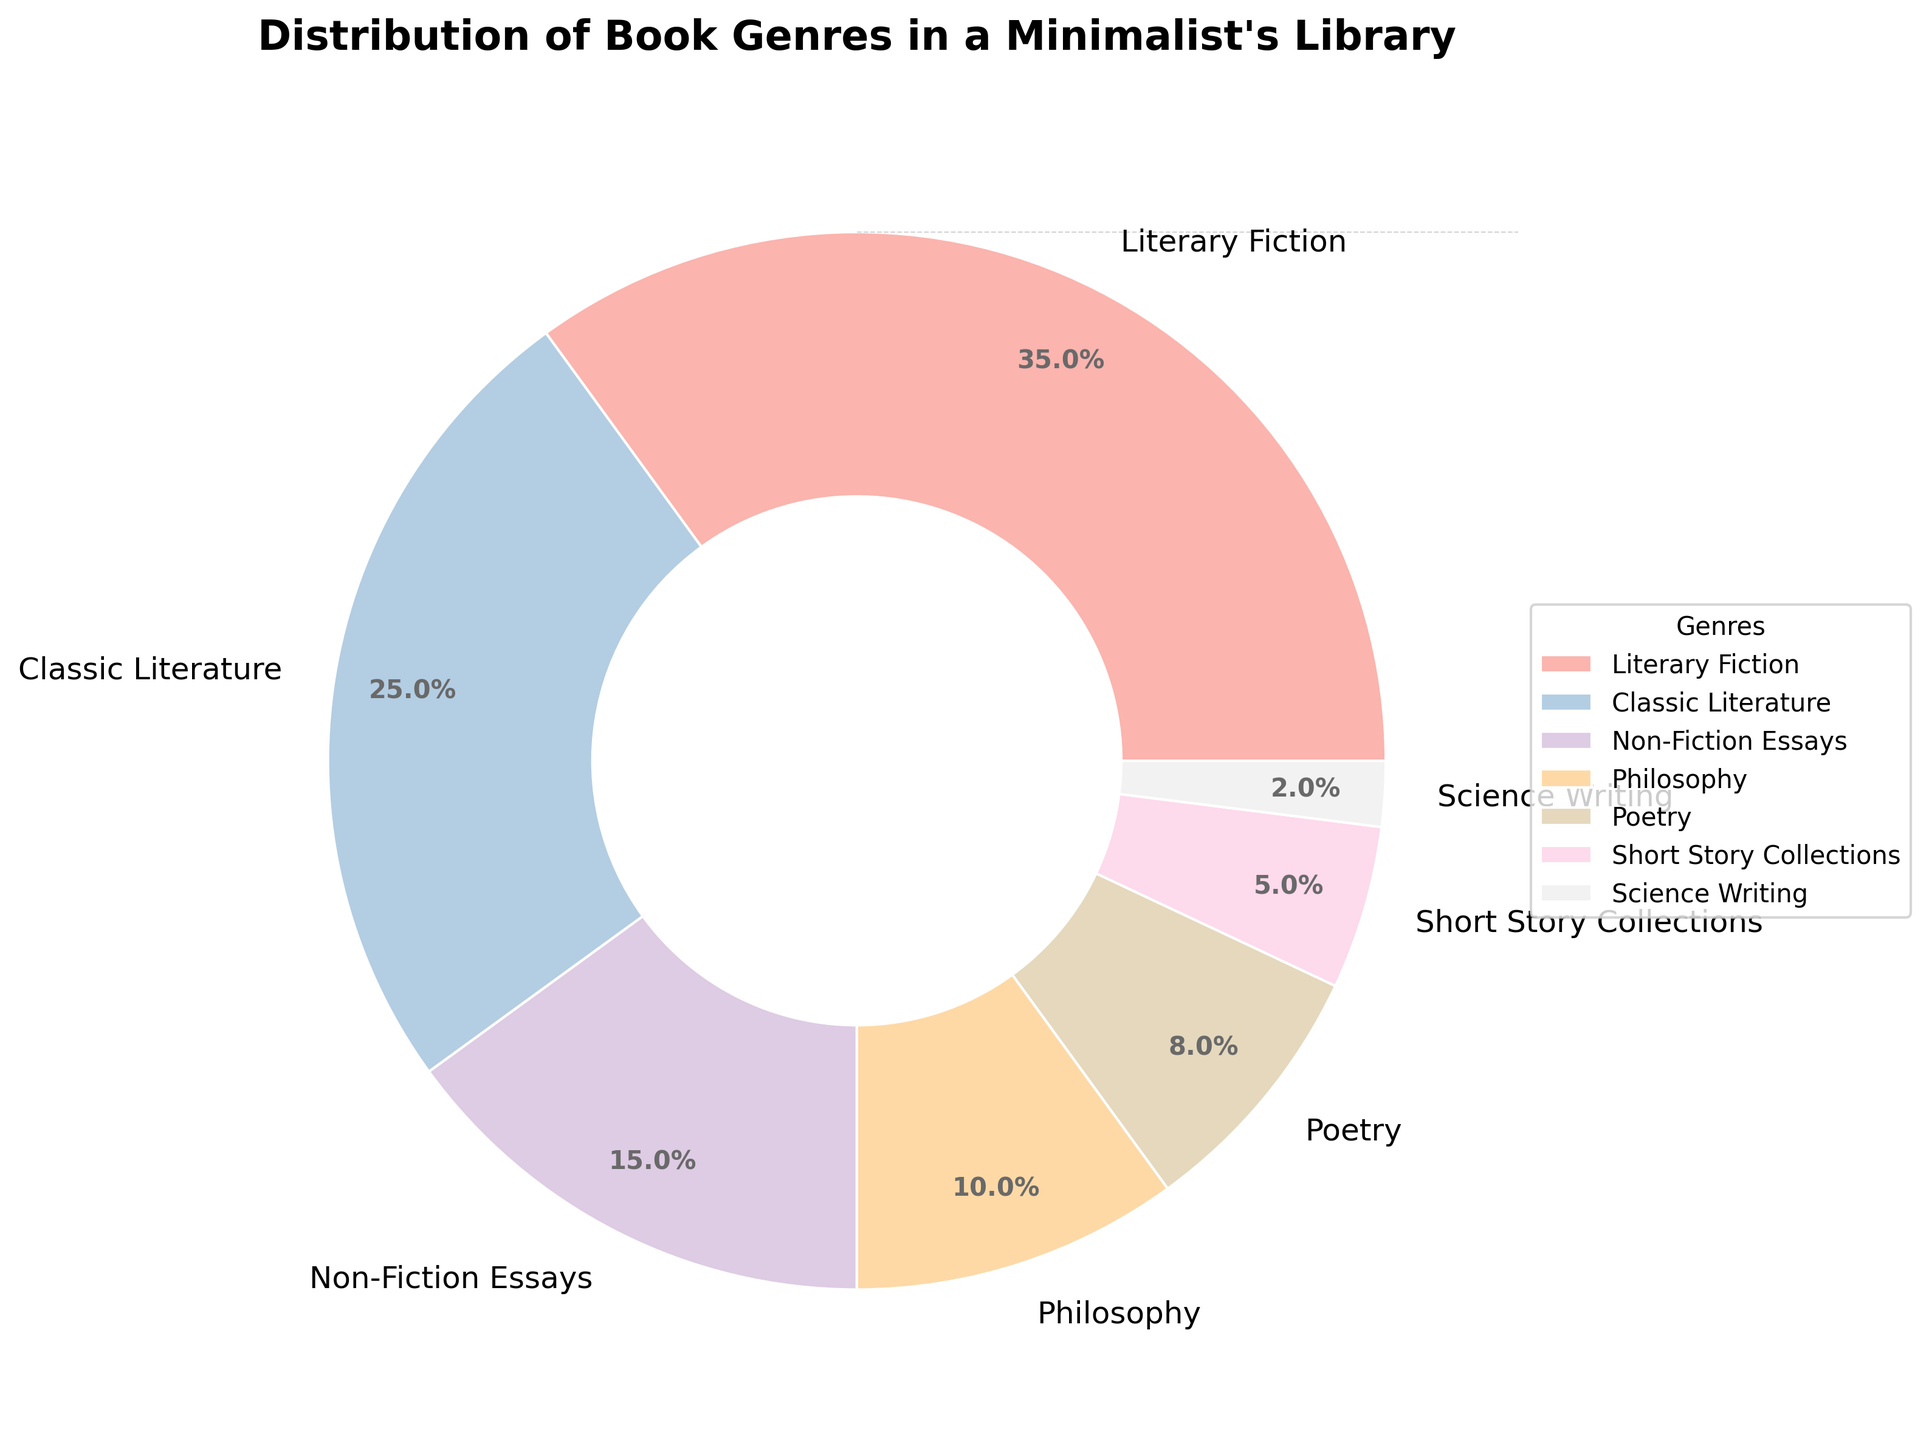what’s the most prevalent book genre in this minimalist's library? The pie chart shows the distribution percentages of different book genres. Look for the genre with the largest slice. “Literary Fiction” occupies the largest proportion, at 35%.
Answer: Literary Fiction Which two genres combined make up exactly half of the library’s total collection? Adding the percentages of "Literary Fiction" (35%) and "Classic Literature" (25%) gives us 60%, which exceeds half. Instead, adding "Classic Literature" (25%) and "Non-Fiction Essays" (15%) sums up to 40%, which is below. However, "Poetry" (8%) and "Short Story Collections" (5%) give us 13%, still below. The correct combination adding up to half is 35% (Literary Fiction) + 15% (Non-Fiction Essays).
Answer: Literary Fiction and Non-Fiction Essays Is the share of Philosophy books greater than the total share of Poetry and Short Story Collections combined? The percentages for Philosophy, Poetry, and Short Story Collections need to be examined. Philosophy is 10%, while Poetry is 8% and Short Story Collections is 5%. Summing Poetry and Short Story Collections results in 13%, which is greater than Philosophy's 10%.
Answer: No What percentage of the library is dedicated to genres other than Literary Fiction and Classic Literature? Subtract the combined percentage of Literary Fiction and Classic Literature from 100%. Literary Fiction is 35% and Classic Literature is 25%, summing up to 60%. Therefore, 100% - 60% = 40%.
Answer: 40% Is the percentage of Science Writing books less than a quarter of the Non-Fiction Essays books? A quarter of Non-Fiction Essays (15%) is calculated as (15/4 = 3.75%). Compare this with the percentage of Science Writing books, which is 2%. Since 2% is less than 3.75%, the percentage of Science Writing books is less than a quarter of Non-Fiction Essays.
Answer: Yes 